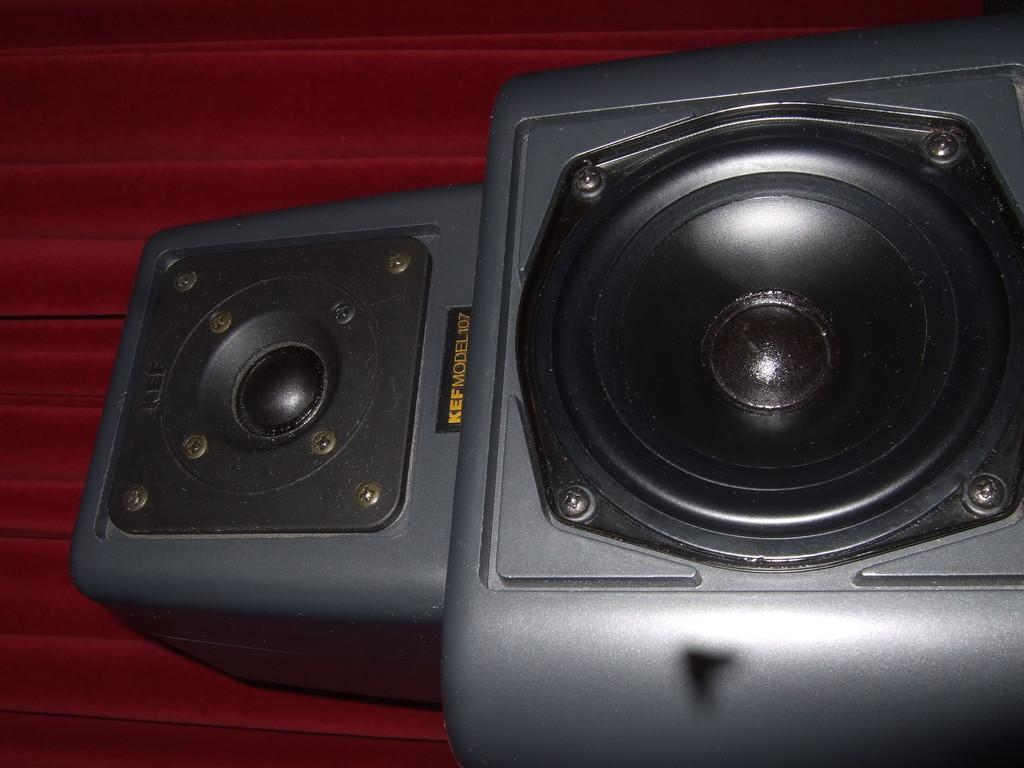What objects are present in the image? There are speakers in the image. Where are the speakers located? The speakers are on a platform. What type of attraction can be seen in the image? There is no attraction present in the image; it only features speakers on a platform. What is the level of friction between the speakers and the platform? The level of friction between the speakers and the platform cannot be determined from the image. 